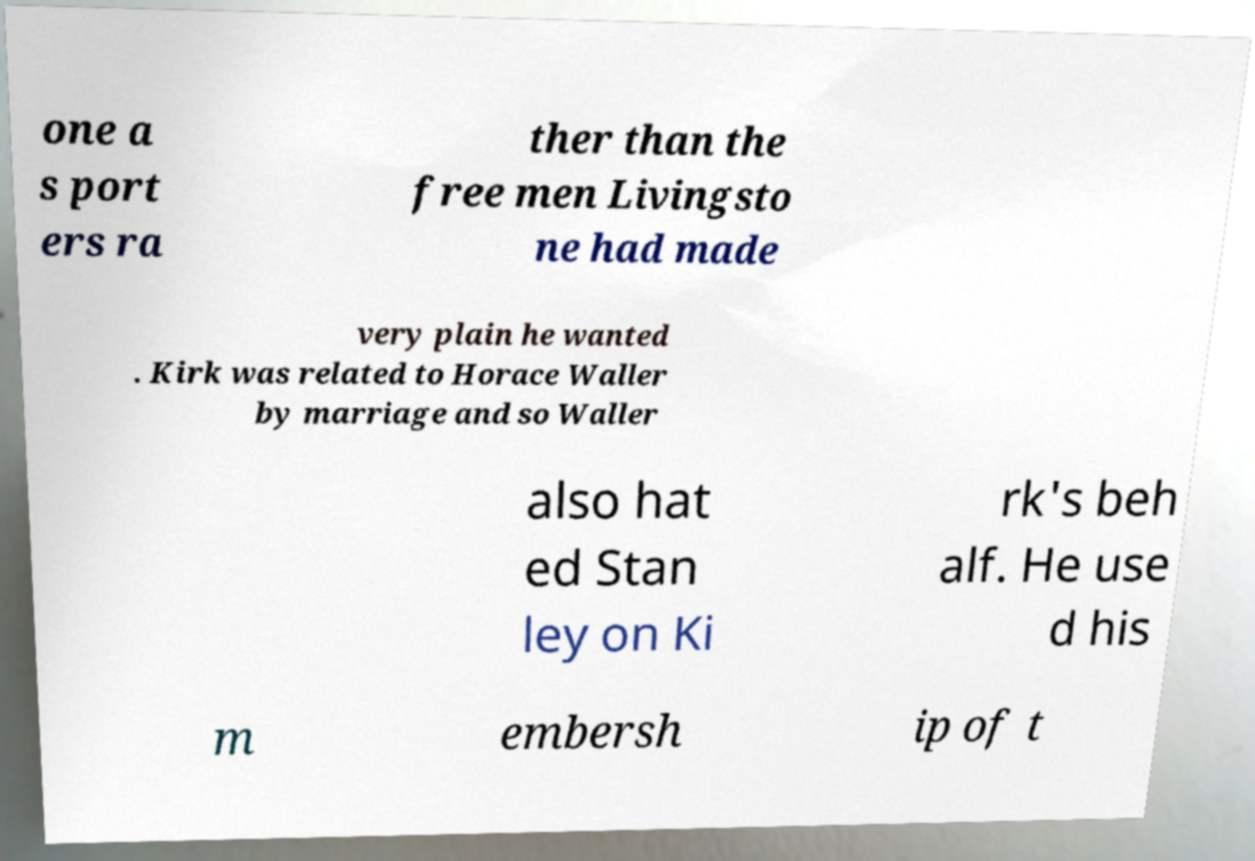For documentation purposes, I need the text within this image transcribed. Could you provide that? one a s port ers ra ther than the free men Livingsto ne had made very plain he wanted . Kirk was related to Horace Waller by marriage and so Waller also hat ed Stan ley on Ki rk's beh alf. He use d his m embersh ip of t 